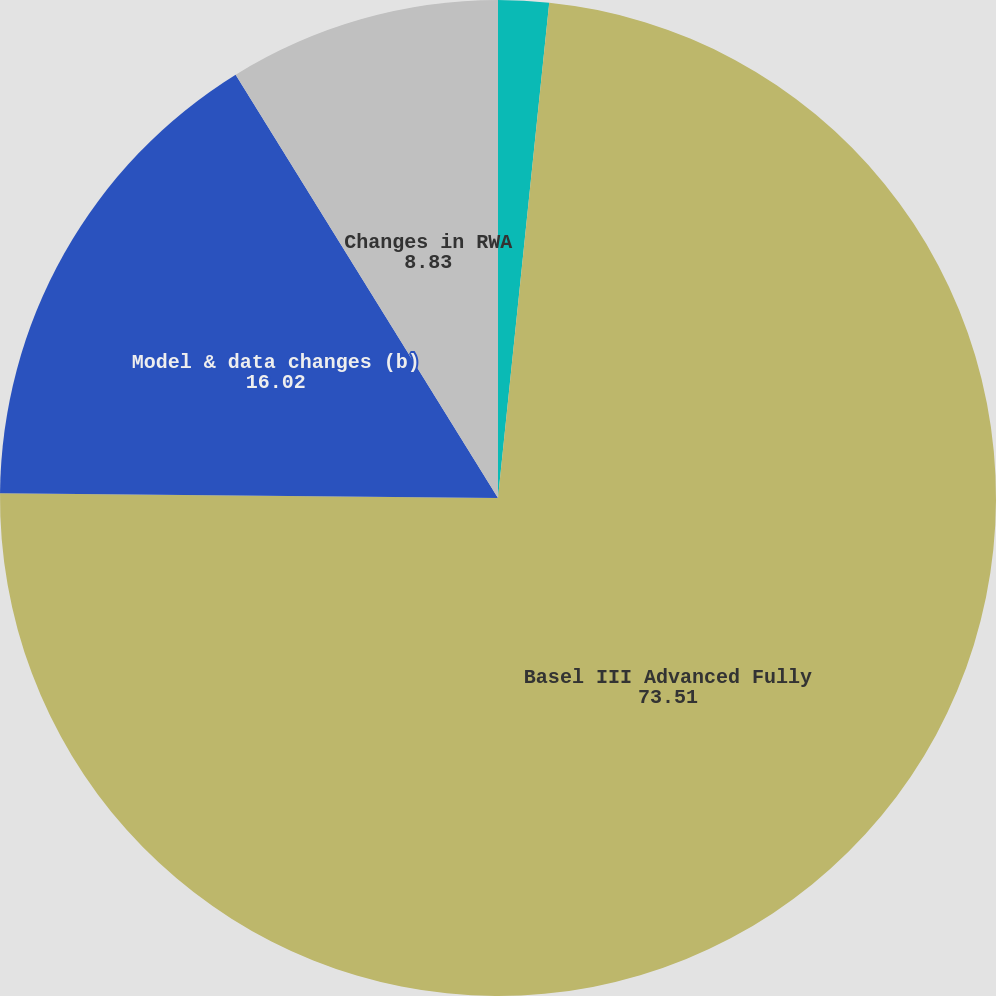<chart> <loc_0><loc_0><loc_500><loc_500><pie_chart><fcel>Effect of rule changes (a)<fcel>Basel III Advanced Fully<fcel>Model & data changes (b)<fcel>Changes in RWA<nl><fcel>1.64%<fcel>73.51%<fcel>16.02%<fcel>8.83%<nl></chart> 